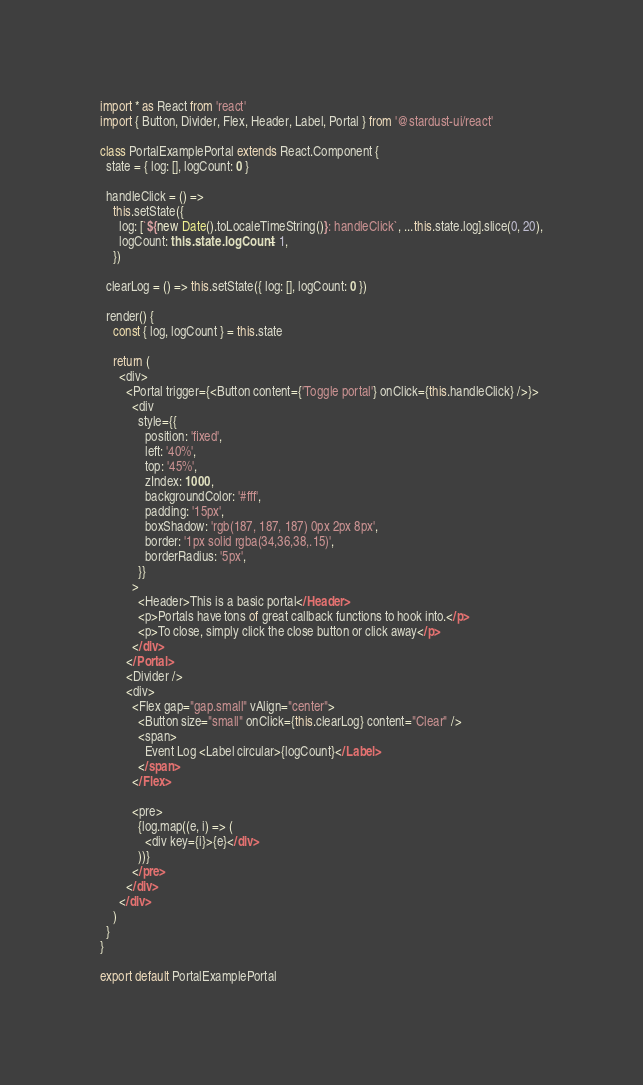Convert code to text. <code><loc_0><loc_0><loc_500><loc_500><_TypeScript_>import * as React from 'react'
import { Button, Divider, Flex, Header, Label, Portal } from '@stardust-ui/react'

class PortalExamplePortal extends React.Component {
  state = { log: [], logCount: 0 }

  handleClick = () =>
    this.setState({
      log: [`${new Date().toLocaleTimeString()}: handleClick`, ...this.state.log].slice(0, 20),
      logCount: this.state.logCount + 1,
    })

  clearLog = () => this.setState({ log: [], logCount: 0 })

  render() {
    const { log, logCount } = this.state

    return (
      <div>
        <Portal trigger={<Button content={'Toggle portal'} onClick={this.handleClick} />}>
          <div
            style={{
              position: 'fixed',
              left: '40%',
              top: '45%',
              zIndex: 1000,
              backgroundColor: '#fff',
              padding: '15px',
              boxShadow: 'rgb(187, 187, 187) 0px 2px 8px',
              border: '1px solid rgba(34,36,38,.15)',
              borderRadius: '5px',
            }}
          >
            <Header>This is a basic portal</Header>
            <p>Portals have tons of great callback functions to hook into.</p>
            <p>To close, simply click the close button or click away</p>
          </div>
        </Portal>
        <Divider />
        <div>
          <Flex gap="gap.small" vAlign="center">
            <Button size="small" onClick={this.clearLog} content="Clear" />
            <span>
              Event Log <Label circular>{logCount}</Label>
            </span>
          </Flex>

          <pre>
            {log.map((e, i) => (
              <div key={i}>{e}</div>
            ))}
          </pre>
        </div>
      </div>
    )
  }
}

export default PortalExamplePortal
</code> 